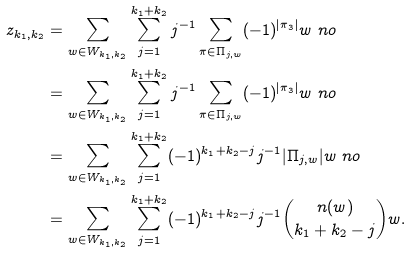<formula> <loc_0><loc_0><loc_500><loc_500>z _ { k _ { 1 } , k _ { 2 } } & = \sum _ { w \in W _ { k _ { 1 } , k _ { 2 } } } \sum _ { j = 1 } ^ { k _ { 1 } + k _ { 2 } } j ^ { - 1 } \sum _ { \pi \in \Pi _ { j , w } } ( - 1 ) ^ { | \pi _ { 3 } | } w \ n o \\ & = \sum _ { w \in W _ { k _ { 1 } , k _ { 2 } } } \sum _ { j = 1 } ^ { k _ { 1 } + k _ { 2 } } j ^ { - 1 } \sum _ { \pi \in \Pi _ { j , w } } ( - 1 ) ^ { | \pi _ { 3 } | } w \ n o \\ & = \sum _ { w \in W _ { k _ { 1 } , k _ { 2 } } } \sum _ { j = 1 } ^ { k _ { 1 } + k _ { 2 } } ( - 1 ) ^ { k _ { 1 } + k _ { 2 } - j } j ^ { - 1 } | \Pi _ { j , w } | w \ n o \\ & = \sum _ { w \in W _ { k _ { 1 } , k _ { 2 } } } \sum _ { j = 1 } ^ { k _ { 1 } + k _ { 2 } } ( - 1 ) ^ { k _ { 1 } + k _ { 2 } - j } j ^ { - 1 } \binom { n ( w ) } { k _ { 1 } + k _ { 2 } - j } w .</formula> 